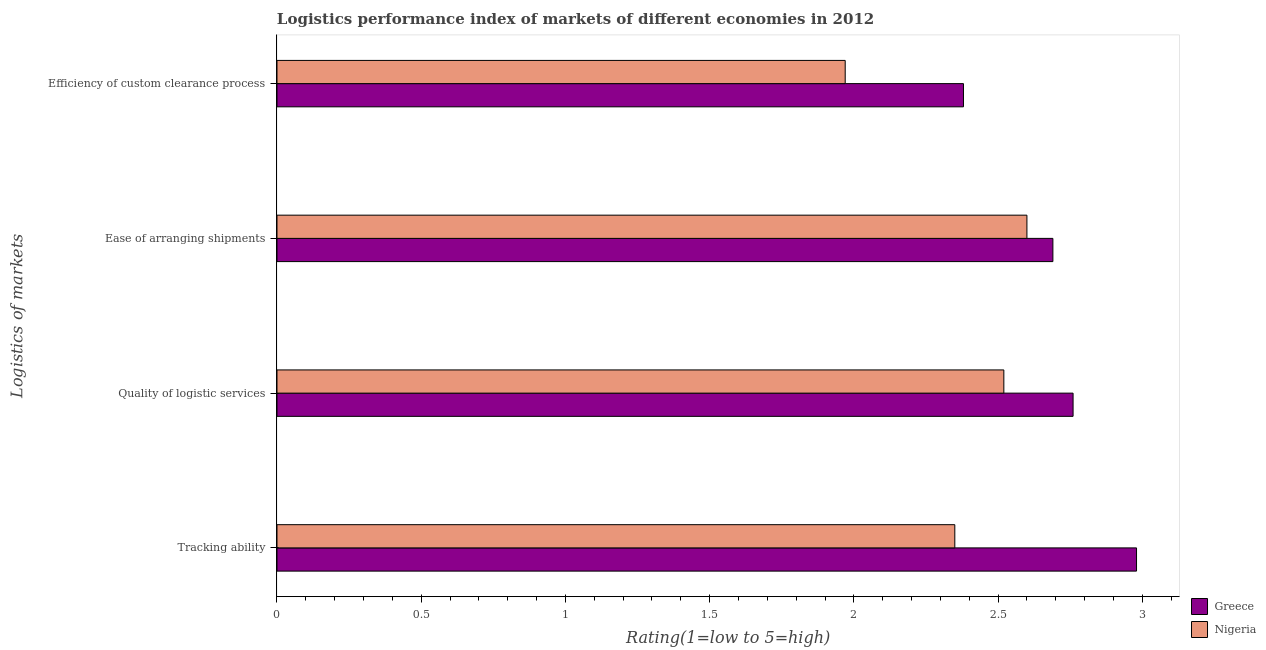How many groups of bars are there?
Keep it short and to the point. 4. Are the number of bars per tick equal to the number of legend labels?
Keep it short and to the point. Yes. How many bars are there on the 3rd tick from the top?
Offer a very short reply. 2. What is the label of the 3rd group of bars from the top?
Your answer should be compact. Quality of logistic services. Across all countries, what is the maximum lpi rating of quality of logistic services?
Ensure brevity in your answer.  2.76. Across all countries, what is the minimum lpi rating of tracking ability?
Offer a very short reply. 2.35. In which country was the lpi rating of tracking ability minimum?
Your answer should be very brief. Nigeria. What is the total lpi rating of efficiency of custom clearance process in the graph?
Your answer should be very brief. 4.35. What is the difference between the lpi rating of quality of logistic services in Nigeria and that in Greece?
Provide a succinct answer. -0.24. What is the difference between the lpi rating of tracking ability in Nigeria and the lpi rating of ease of arranging shipments in Greece?
Ensure brevity in your answer.  -0.34. What is the average lpi rating of ease of arranging shipments per country?
Offer a very short reply. 2.65. What is the difference between the lpi rating of ease of arranging shipments and lpi rating of tracking ability in Nigeria?
Provide a succinct answer. 0.25. What is the ratio of the lpi rating of quality of logistic services in Nigeria to that in Greece?
Provide a succinct answer. 0.91. Is the lpi rating of efficiency of custom clearance process in Nigeria less than that in Greece?
Give a very brief answer. Yes. What is the difference between the highest and the second highest lpi rating of quality of logistic services?
Offer a very short reply. 0.24. What is the difference between the highest and the lowest lpi rating of quality of logistic services?
Your answer should be compact. 0.24. In how many countries, is the lpi rating of ease of arranging shipments greater than the average lpi rating of ease of arranging shipments taken over all countries?
Provide a short and direct response. 1. Is it the case that in every country, the sum of the lpi rating of ease of arranging shipments and lpi rating of efficiency of custom clearance process is greater than the sum of lpi rating of tracking ability and lpi rating of quality of logistic services?
Offer a terse response. No. What does the 1st bar from the top in Efficiency of custom clearance process represents?
Make the answer very short. Nigeria. What does the 2nd bar from the bottom in Efficiency of custom clearance process represents?
Provide a succinct answer. Nigeria. Is it the case that in every country, the sum of the lpi rating of tracking ability and lpi rating of quality of logistic services is greater than the lpi rating of ease of arranging shipments?
Ensure brevity in your answer.  Yes. How many bars are there?
Offer a terse response. 8. What is the difference between two consecutive major ticks on the X-axis?
Your answer should be compact. 0.5. Does the graph contain any zero values?
Keep it short and to the point. No. Does the graph contain grids?
Your answer should be very brief. No. Where does the legend appear in the graph?
Ensure brevity in your answer.  Bottom right. How many legend labels are there?
Provide a short and direct response. 2. How are the legend labels stacked?
Your response must be concise. Vertical. What is the title of the graph?
Provide a short and direct response. Logistics performance index of markets of different economies in 2012. Does "Estonia" appear as one of the legend labels in the graph?
Your answer should be very brief. No. What is the label or title of the X-axis?
Give a very brief answer. Rating(1=low to 5=high). What is the label or title of the Y-axis?
Your answer should be very brief. Logistics of markets. What is the Rating(1=low to 5=high) in Greece in Tracking ability?
Offer a very short reply. 2.98. What is the Rating(1=low to 5=high) in Nigeria in Tracking ability?
Give a very brief answer. 2.35. What is the Rating(1=low to 5=high) of Greece in Quality of logistic services?
Your response must be concise. 2.76. What is the Rating(1=low to 5=high) of Nigeria in Quality of logistic services?
Your answer should be compact. 2.52. What is the Rating(1=low to 5=high) of Greece in Ease of arranging shipments?
Give a very brief answer. 2.69. What is the Rating(1=low to 5=high) in Greece in Efficiency of custom clearance process?
Make the answer very short. 2.38. What is the Rating(1=low to 5=high) in Nigeria in Efficiency of custom clearance process?
Your answer should be compact. 1.97. Across all Logistics of markets, what is the maximum Rating(1=low to 5=high) of Greece?
Offer a terse response. 2.98. Across all Logistics of markets, what is the maximum Rating(1=low to 5=high) of Nigeria?
Your answer should be compact. 2.6. Across all Logistics of markets, what is the minimum Rating(1=low to 5=high) of Greece?
Give a very brief answer. 2.38. Across all Logistics of markets, what is the minimum Rating(1=low to 5=high) in Nigeria?
Your answer should be very brief. 1.97. What is the total Rating(1=low to 5=high) in Greece in the graph?
Keep it short and to the point. 10.81. What is the total Rating(1=low to 5=high) in Nigeria in the graph?
Your answer should be very brief. 9.44. What is the difference between the Rating(1=low to 5=high) of Greece in Tracking ability and that in Quality of logistic services?
Provide a succinct answer. 0.22. What is the difference between the Rating(1=low to 5=high) in Nigeria in Tracking ability and that in Quality of logistic services?
Your response must be concise. -0.17. What is the difference between the Rating(1=low to 5=high) of Greece in Tracking ability and that in Ease of arranging shipments?
Ensure brevity in your answer.  0.29. What is the difference between the Rating(1=low to 5=high) in Nigeria in Tracking ability and that in Ease of arranging shipments?
Your answer should be compact. -0.25. What is the difference between the Rating(1=low to 5=high) in Greece in Tracking ability and that in Efficiency of custom clearance process?
Your response must be concise. 0.6. What is the difference between the Rating(1=low to 5=high) in Nigeria in Tracking ability and that in Efficiency of custom clearance process?
Provide a short and direct response. 0.38. What is the difference between the Rating(1=low to 5=high) of Greece in Quality of logistic services and that in Ease of arranging shipments?
Offer a very short reply. 0.07. What is the difference between the Rating(1=low to 5=high) in Nigeria in Quality of logistic services and that in Ease of arranging shipments?
Your answer should be very brief. -0.08. What is the difference between the Rating(1=low to 5=high) of Greece in Quality of logistic services and that in Efficiency of custom clearance process?
Keep it short and to the point. 0.38. What is the difference between the Rating(1=low to 5=high) in Nigeria in Quality of logistic services and that in Efficiency of custom clearance process?
Offer a terse response. 0.55. What is the difference between the Rating(1=low to 5=high) of Greece in Ease of arranging shipments and that in Efficiency of custom clearance process?
Provide a succinct answer. 0.31. What is the difference between the Rating(1=low to 5=high) in Nigeria in Ease of arranging shipments and that in Efficiency of custom clearance process?
Your answer should be very brief. 0.63. What is the difference between the Rating(1=low to 5=high) of Greece in Tracking ability and the Rating(1=low to 5=high) of Nigeria in Quality of logistic services?
Offer a very short reply. 0.46. What is the difference between the Rating(1=low to 5=high) in Greece in Tracking ability and the Rating(1=low to 5=high) in Nigeria in Ease of arranging shipments?
Your answer should be compact. 0.38. What is the difference between the Rating(1=low to 5=high) in Greece in Quality of logistic services and the Rating(1=low to 5=high) in Nigeria in Ease of arranging shipments?
Keep it short and to the point. 0.16. What is the difference between the Rating(1=low to 5=high) in Greece in Quality of logistic services and the Rating(1=low to 5=high) in Nigeria in Efficiency of custom clearance process?
Provide a succinct answer. 0.79. What is the difference between the Rating(1=low to 5=high) of Greece in Ease of arranging shipments and the Rating(1=low to 5=high) of Nigeria in Efficiency of custom clearance process?
Ensure brevity in your answer.  0.72. What is the average Rating(1=low to 5=high) in Greece per Logistics of markets?
Give a very brief answer. 2.7. What is the average Rating(1=low to 5=high) of Nigeria per Logistics of markets?
Provide a short and direct response. 2.36. What is the difference between the Rating(1=low to 5=high) in Greece and Rating(1=low to 5=high) in Nigeria in Tracking ability?
Keep it short and to the point. 0.63. What is the difference between the Rating(1=low to 5=high) in Greece and Rating(1=low to 5=high) in Nigeria in Quality of logistic services?
Give a very brief answer. 0.24. What is the difference between the Rating(1=low to 5=high) of Greece and Rating(1=low to 5=high) of Nigeria in Ease of arranging shipments?
Offer a very short reply. 0.09. What is the difference between the Rating(1=low to 5=high) of Greece and Rating(1=low to 5=high) of Nigeria in Efficiency of custom clearance process?
Your answer should be compact. 0.41. What is the ratio of the Rating(1=low to 5=high) of Greece in Tracking ability to that in Quality of logistic services?
Your answer should be very brief. 1.08. What is the ratio of the Rating(1=low to 5=high) of Nigeria in Tracking ability to that in Quality of logistic services?
Your answer should be compact. 0.93. What is the ratio of the Rating(1=low to 5=high) in Greece in Tracking ability to that in Ease of arranging shipments?
Your answer should be very brief. 1.11. What is the ratio of the Rating(1=low to 5=high) in Nigeria in Tracking ability to that in Ease of arranging shipments?
Give a very brief answer. 0.9. What is the ratio of the Rating(1=low to 5=high) in Greece in Tracking ability to that in Efficiency of custom clearance process?
Provide a short and direct response. 1.25. What is the ratio of the Rating(1=low to 5=high) in Nigeria in Tracking ability to that in Efficiency of custom clearance process?
Provide a short and direct response. 1.19. What is the ratio of the Rating(1=low to 5=high) of Nigeria in Quality of logistic services to that in Ease of arranging shipments?
Offer a terse response. 0.97. What is the ratio of the Rating(1=low to 5=high) in Greece in Quality of logistic services to that in Efficiency of custom clearance process?
Give a very brief answer. 1.16. What is the ratio of the Rating(1=low to 5=high) of Nigeria in Quality of logistic services to that in Efficiency of custom clearance process?
Your answer should be very brief. 1.28. What is the ratio of the Rating(1=low to 5=high) of Greece in Ease of arranging shipments to that in Efficiency of custom clearance process?
Offer a very short reply. 1.13. What is the ratio of the Rating(1=low to 5=high) in Nigeria in Ease of arranging shipments to that in Efficiency of custom clearance process?
Provide a succinct answer. 1.32. What is the difference between the highest and the second highest Rating(1=low to 5=high) of Greece?
Offer a very short reply. 0.22. What is the difference between the highest and the second highest Rating(1=low to 5=high) in Nigeria?
Your response must be concise. 0.08. What is the difference between the highest and the lowest Rating(1=low to 5=high) in Nigeria?
Provide a short and direct response. 0.63. 